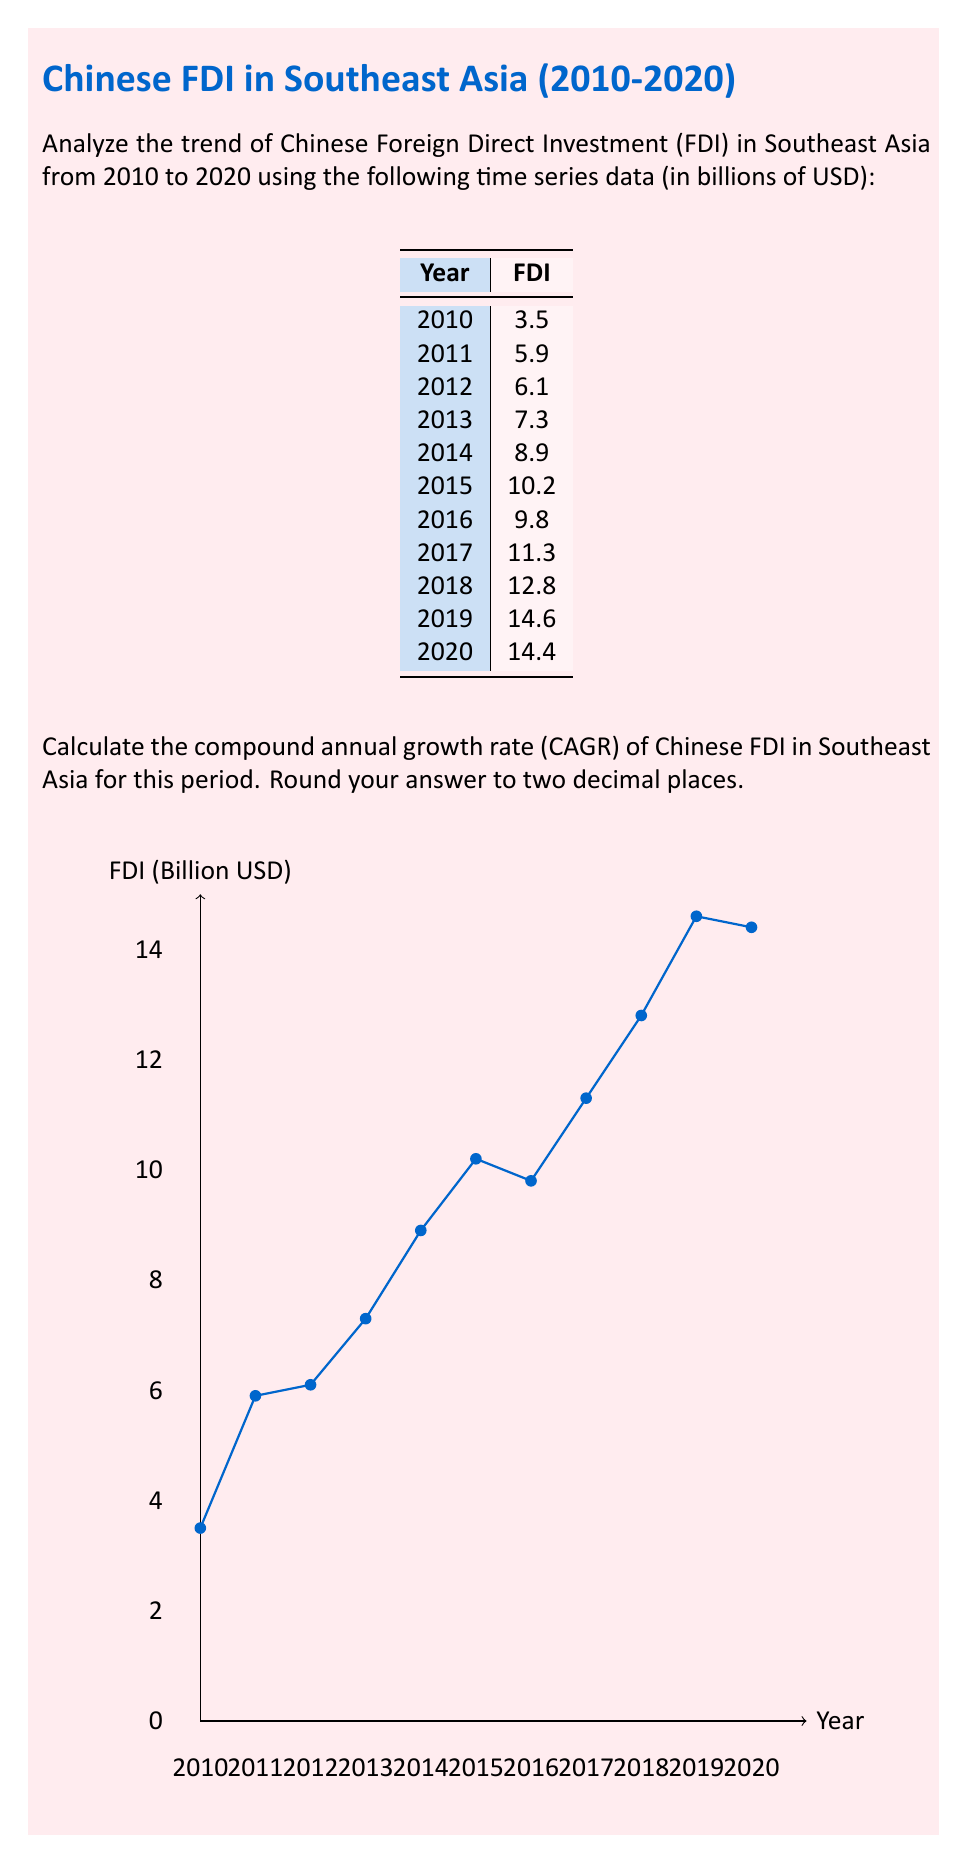Provide a solution to this math problem. To calculate the Compound Annual Growth Rate (CAGR) of Chinese FDI in Southeast Asia from 2010 to 2020, we'll use the following formula:

$$ CAGR = \left(\frac{Ending Value}{Beginning Value}\right)^{\frac{1}{n}} - 1 $$

Where:
- Ending Value is the FDI value in 2020
- Beginning Value is the FDI value in 2010
- n is the number of years (2020 - 2010 = 10 years)

Step 1: Identify the values
- Ending Value (2020 FDI) = $14.4 billion
- Beginning Value (2010 FDI) = $3.5 billion
- n = 10 years

Step 2: Plug the values into the CAGR formula

$$ CAGR = \left(\frac{14.4}{3.5}\right)^{\frac{1}{10}} - 1 $$

Step 3: Calculate the value inside the parentheses
$$ CAGR = (4.1143)^{\frac{1}{10}} - 1 $$

Step 4: Calculate the 10th root
$$ CAGR = 1.1518 - 1 $$

Step 5: Subtract 1 and convert to percentage
$$ CAGR = 0.1518 = 15.18\% $$

Step 6: Round to two decimal places
$$ CAGR = 15.18\% $$

Therefore, the Compound Annual Growth Rate of Chinese FDI in Southeast Asia from 2010 to 2020 is 15.18%.
Answer: 15.18% 